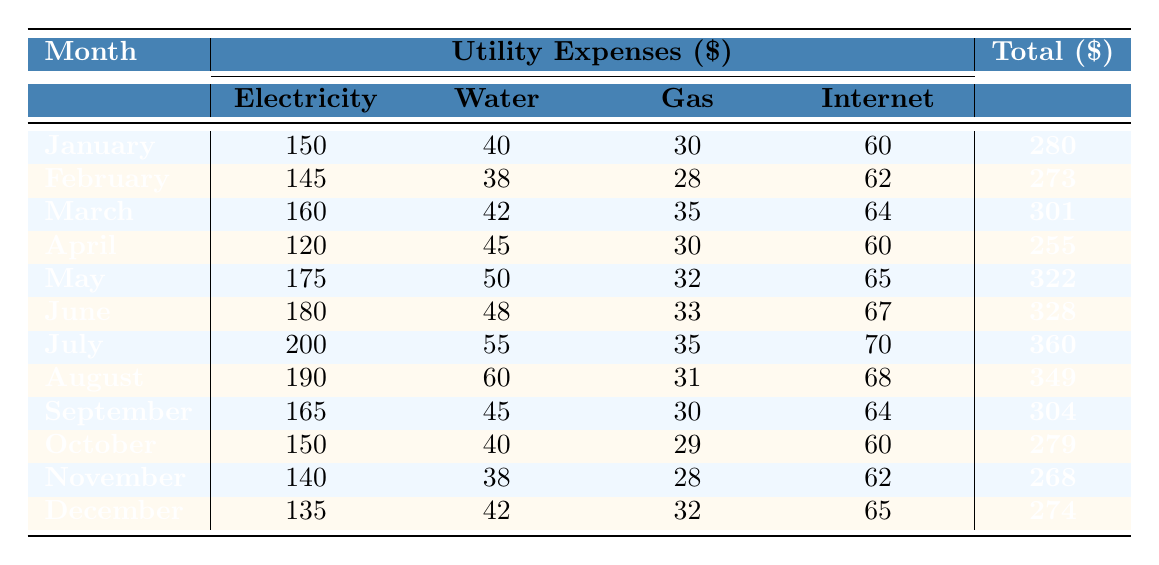What was the highest utility expense recorded in 2022? The total expenses are listed for each month. By scanning through the total values, I see that the highest value is 360 in July.
Answer: 360 In which month was the electricity expense the lowest? Looking at the electricity amounts for each month, the lowest value is 120, which occurs in April.
Answer: April What was the average monthly water expense in 2022? To find the average, I first add the water expenses: (40 + 38 + 42 + 45 + 50 + 48 + 55 + 60 + 45 + 40 + 38 + 42) = 540. There are 12 months, so the average is 540/12 = 45.
Answer: 45 Did the total utility expenses increase from March to April? The total for March is 301 and for April is 255. Since 301 > 255, the total decreased.
Answer: No What is the total utility expense for the first half of the year (January to June)? I add the total expenses for the first six months: 280 + 273 + 301 + 255 + 322 + 328 = 1,759.
Answer: 1,759 Which provider had the highest gas expense in any month? The highest gas expense is 35 in March, provided by Peoples Gas.
Answer: 35 (Peoples Gas) What is the difference in total expenses from May to June? The total expense for May is 322, and for June it’s 328. The difference is 328 - 322 = 6.
Answer: 6 In which month was the combined expense for gas and internet the highest? I calculate the combined expense for gas and internet for each month. The highest combined expense is 140 (70 for gas and 70 for internet) in July.
Answer: July What percentage of the total utility expenses for the year was spent on electricity? The total yearly expense is 3,397 (adding all monthly totals). The total electricity expense sums to 1,800 (adding all electricity amounts). The percentage is (1,800 / 3,397) * 100 ≈ 53.0%.
Answer: 53.0% Was there a month where the total expenses were below 300? Checking the total expenses, I see the totals for January, February, April, October, November, and December are below 300.
Answer: Yes 